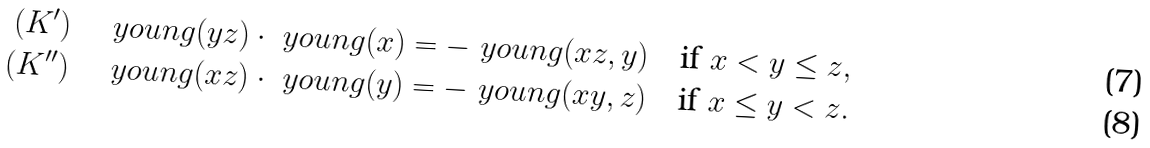<formula> <loc_0><loc_0><loc_500><loc_500>( K ^ { \prime } ) \quad & \ y o u n g ( y z ) \cdot \ y o u n g ( x ) = - \ y o u n g ( x z , y ) \quad \text {if } x < y \leq z , \\ ( K ^ { \prime \prime } ) \quad & \ y o u n g ( x z ) \cdot \ y o u n g ( y ) = - \ y o u n g ( x y , z ) \quad \text {if } x \leq y < z .</formula> 